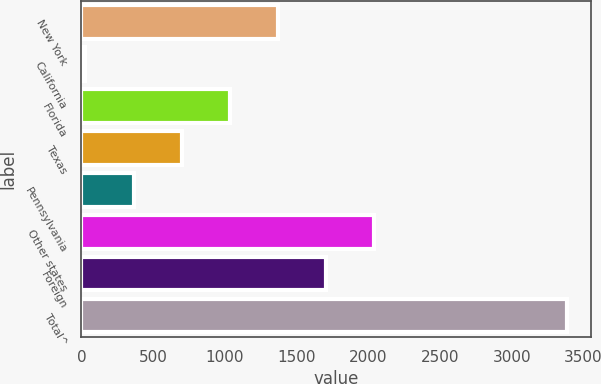Convert chart. <chart><loc_0><loc_0><loc_500><loc_500><bar_chart><fcel>New York<fcel>California<fcel>Florida<fcel>Texas<fcel>Pennsylvania<fcel>Other states<fcel>Foreign<fcel>Total^<nl><fcel>1371<fcel>29<fcel>1035.5<fcel>700<fcel>364.5<fcel>2042<fcel>1706.5<fcel>3384<nl></chart> 